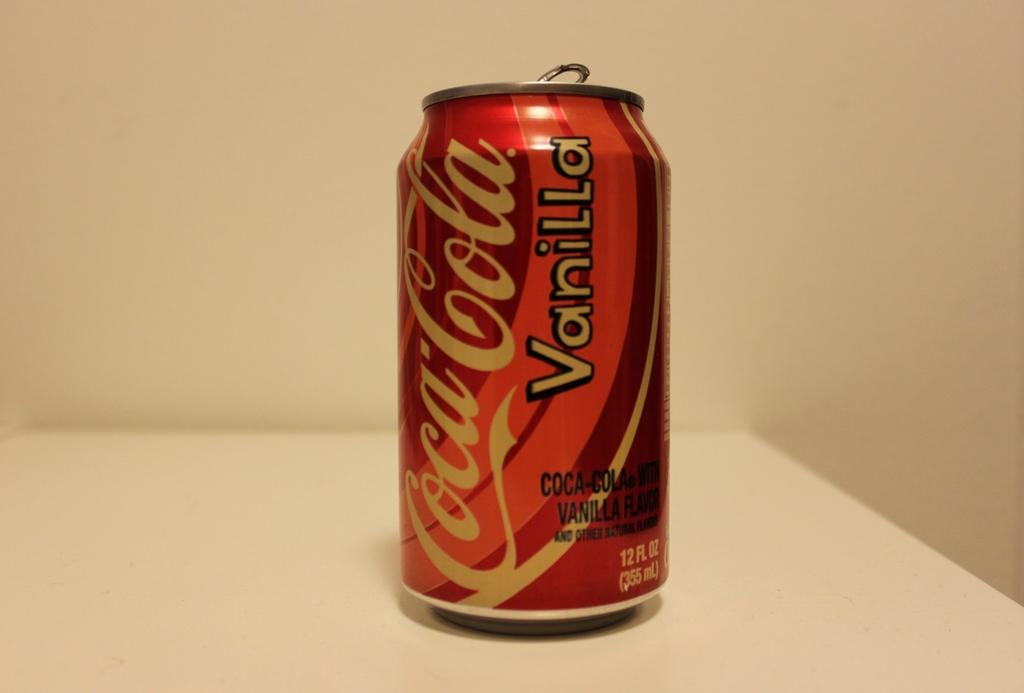<image>
Render a clear and concise summary of the photo. Red Coca Cola Vanilla can on top of a white surface. 